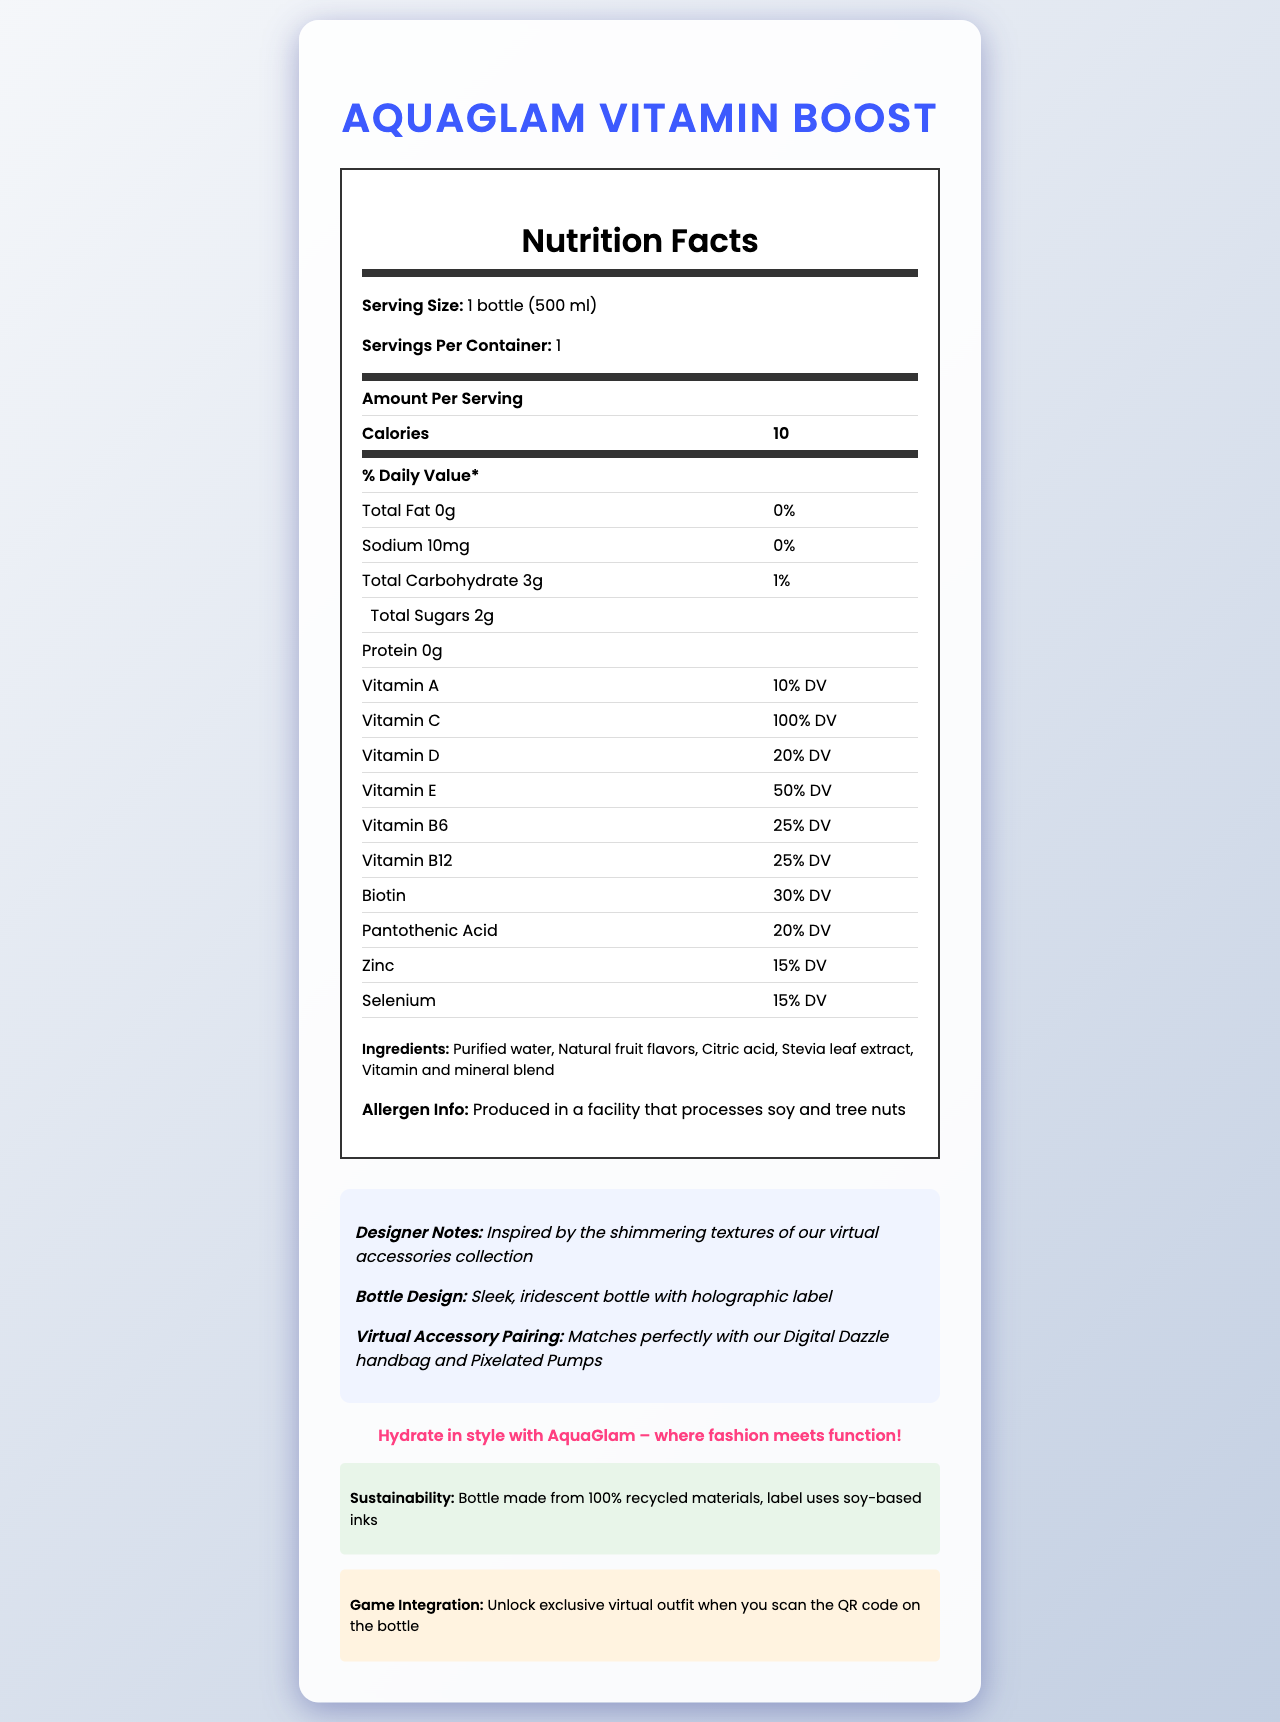what is the serving size for AquaGlam Vitamin Boost? The serving size is explicitly stated in the document as "1 bottle (500 ml)".
Answer: 1 bottle (500 ml) what are the total carbohydrates per serving? The total carbohydrates per serving are listed as 3g in the nutrition facts table.
Answer: 3g how much vitamin C is provided per serving? The document states that one serving provides 100% of the daily value for vitamin C.
Answer: 100% DV list three main ingredients in AquaGlam Vitamin Boost. The first three ingredients listed are "Purified water", "Natural fruit flavors", and "Citric acid".
Answer: Purified water, Natural fruit flavors, Citric acid what is the total calorie content per bottle? The nutrition label shows that the calorie content per bottle is 10 calories.
Answer: 10 calories which vitamin is present at the highest daily value percentage? A. Vitamin A B. Vitamin C C. Vitamin D D. Vitamin E The document states Vitamin C provides 100% DV per serving, which is the highest percentage among the listed vitamins.
Answer: B what amount of sodium is listed in the nutrition facts? The nutrition facts report 10mg of sodium per serving.
Answer: 10mg what percentage of daily value does biotin provide? According to the nutrition label, biotin provides 30% of the daily value.
Answer: 30% DV is the product allergen-free? The allergen info section indicates that the product is produced in a facility that processes soy and tree nuts, meaning it is not allergen-free.
Answer: No which fashion items does AquaGlam Vitamin Boost pair with? A. Digital Dazzle handbag B. Sparkling Shoes C. Pixelated Pumps D. Both A & C The document states that it pairs with the "Digital Dazzle handbag and Pixelated Pumps."
Answer: D does AquaGlam Vitamin Boost contain any fat? The nutrition facts specify that the total fat content is 0g, meaning it contains no fat.
Answer: No describe the bottle design. The document describes the bottle design as "Sleek, iridescent bottle with holographic label."
Answer: Sleek, iridescent bottle with holographic label does the label use eco-friendly materials? According to the sustainability information, the label uses soy-based inks, which are eco-friendly.
Answer: Yes summarize the main features of AquaGlam Vitamin Boost. The document provides comprehensive information about the product's nutritional contents, ingredients, allergen info, bottle design, and sustainability. Additionally, it highlights its pairing with virtual accessories and game integration features.
Answer: AquaGlam Vitamin Boost is a vitamin-enriched water bottle offering various vitamins and minerals with only 10 calories per 500 ml serving. It comes in a sleek, iridescent bottle with a holographic label and pairs with virtual accessories like the Digital Dazzle handbag and Pixelated Pumps. The bottle is made from 100% recycled materials and uses soy-based inks. A QR code on the bottle unlocks exclusive virtual outfits in a game. did the document state the production cost of AquaGlam Vitamin Boost? The document does not provide any details about the production cost of AquaGlam Vitamin Boost.
Answer: Not enough information 